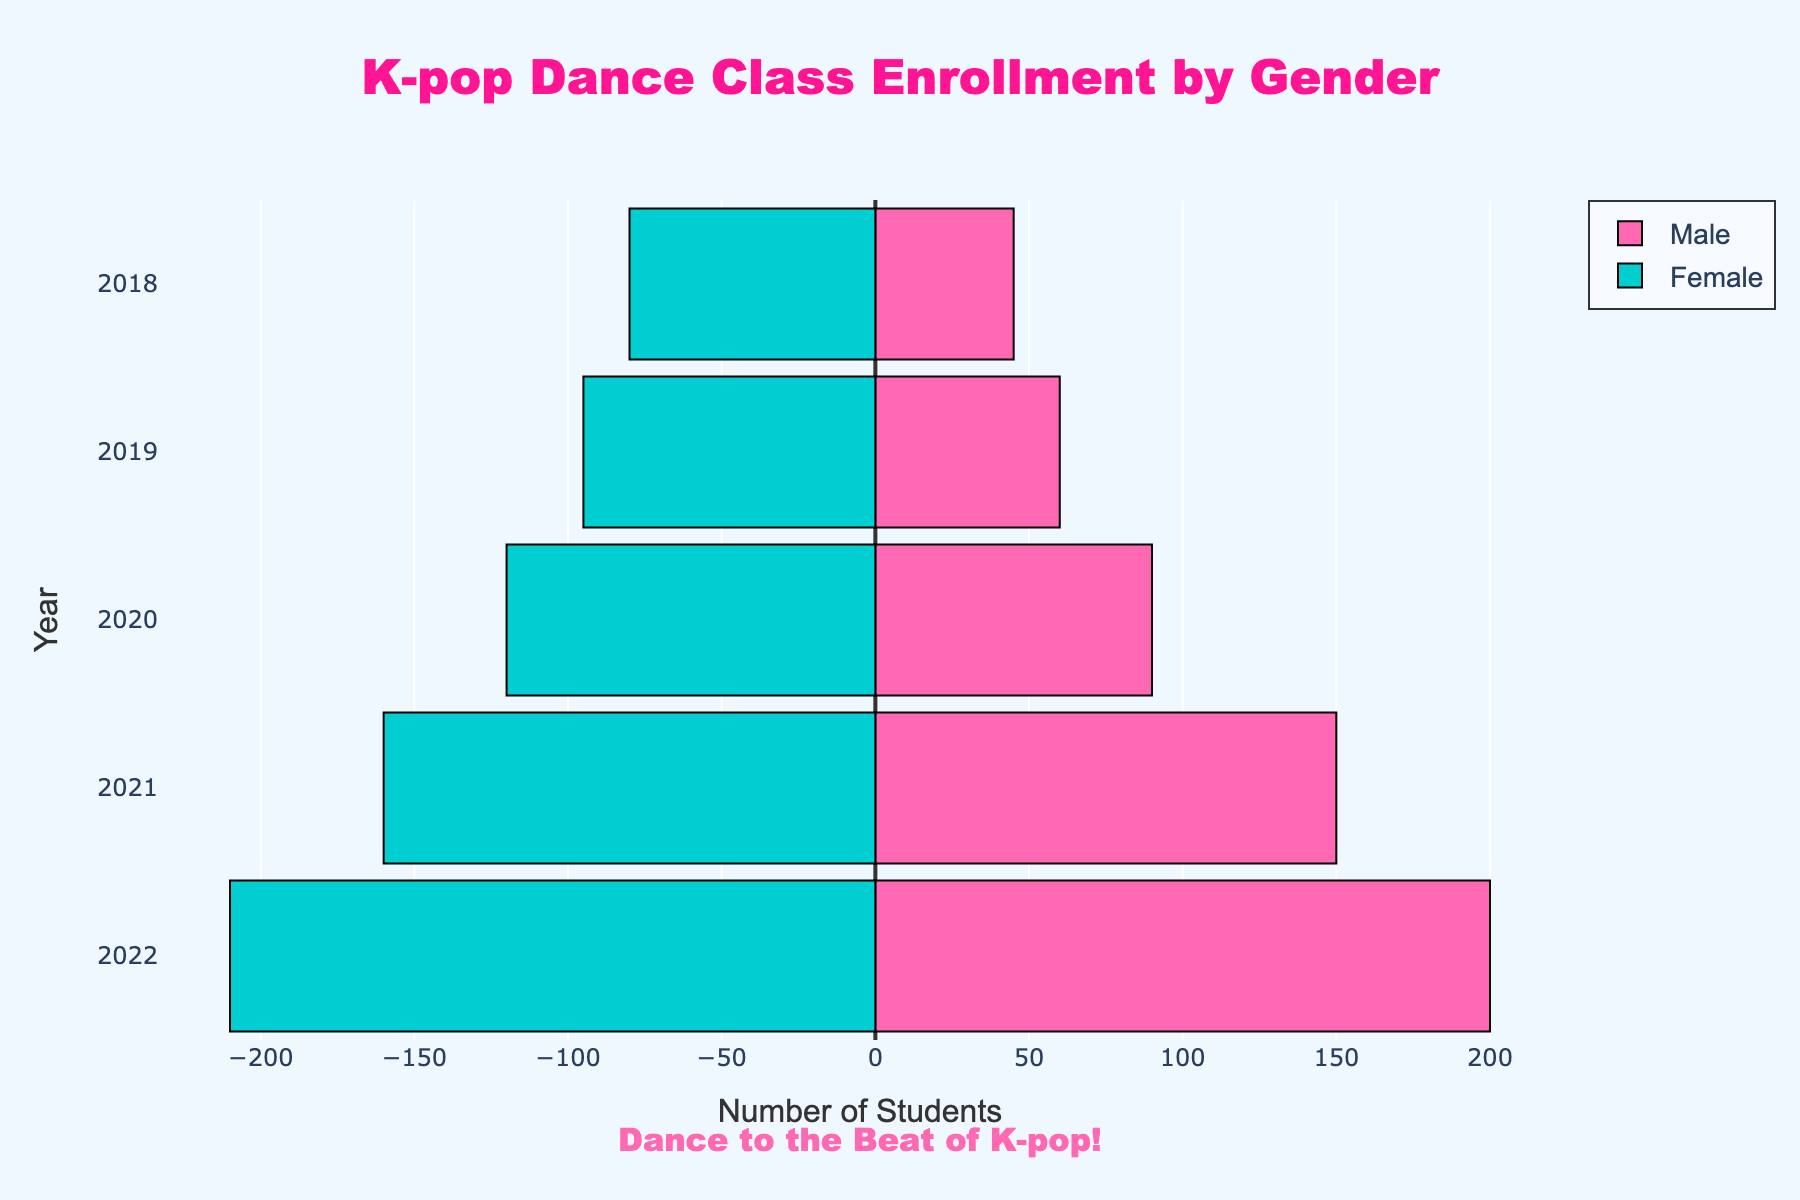What is the total enrollment of male and female students in 2021? First, find the enrollment for males in 2021, which is 150, and for females in 2021, which is 160. Add them together to get the total enrollment: 150 + 160 = 310.
Answer: 310 Which year had the highest enrollment for male students? Look at the bars representing male enrollment across all years and identify the year with the longest bar. The longest bar for male students is in 2022 with an enrollment of 200.
Answer: 2022 What is the percentage increase in female enrollment from 2018 to 2022? Find the female enrollment in 2018, which is 80, and in 2022, which is 210. Calculate the increase by subtracting 80 from 210 to get 130. Then, divide the increase by the original number (80) and multiply by 100: (130 / 80) * 100 = 162.5%.
Answer: 162.5% Between male and female students, who had a greater increase in enrollment from 2019 to 2020? Find the enrollment for males in 2019 and 2020 (60 and 90 respectively), and for females in 2019 and 2020 (95 and 120 respectively). Calculate the increase for males: 90 - 60 = 30, and for females: 120 - 95 = 25. The male increase is larger (30 > 25).
Answer: Male How did the growth trend of male enrollment compare to female enrollment from 2018 to 2022? Observe the general direction and magnitude of the bars for both genders over the years. Both groups show an increasing trend, but male enrollment shows a sharper rise, especially between 2019 and 2021.
Answer: Males grew faster Which gender had a higher enrollment in 2019? Compare the length of the bars for males and females in 2019. The female bar is longer, with 95 students compared to 60 male students.
Answer: Female What is the difference in total enrollment between male and female students over the five years? Sum up the enrollments for each gender over the years: 
    - Males: 45 + 60 + 90 + 150 + 200 = 545
    - Females: 80 + 95 + 120 + 160 + 210 = 665
Then, find the difference: 665 - 545 = 120.
Answer: 120 How many more male students enrolled in 2020 compared to 2018? Find the enrollment for males in 2018 and 2020 (45 and 90 respectively). Calculate the difference: 90 - 45 = 45.
Answer: 45 Do both male and female enrollments reach their peak in the same year? Identify the year with the highest enrollment for both genders. Both genders reached their peak enrollment in 2022, with males at 200 and females at 210.
Answer: Yes 